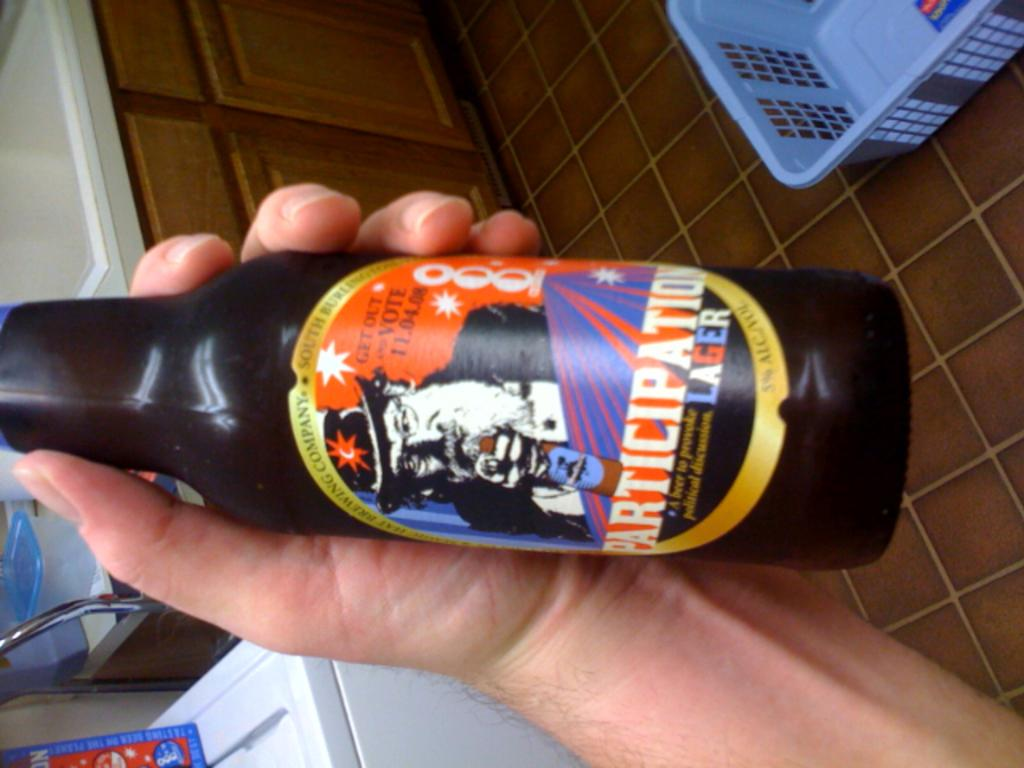<image>
Write a terse but informative summary of the picture. A person is holding a bottle of beer that says Participation Lager. 